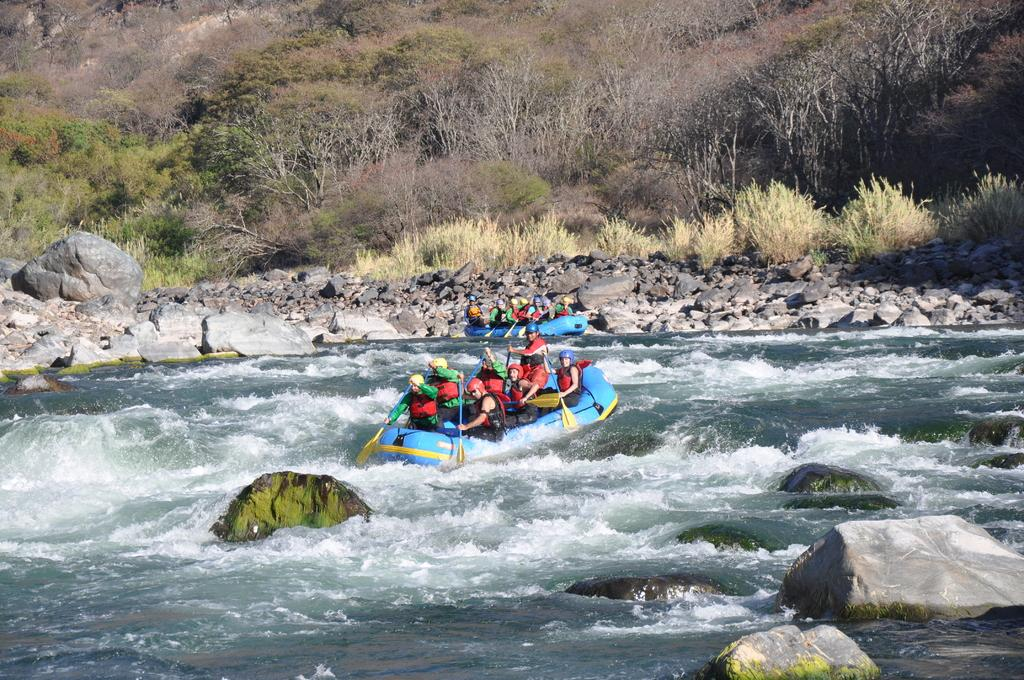What are the people in the image doing? The people in the image are sitting on boats. What are the people holding in their hands? The people are holding rows in their hands. Where are the boats located? The boats are on the water. What can be seen in the background of the image? There are trees and rocks and stones in the background of the image. What type of grass is being used for arithmetic calculations in the image? There is no grass or arithmetic calculations present in the image. What kind of paste is being applied to the rocks and stones in the image? There is no paste being applied to the rocks and stones in the image. 